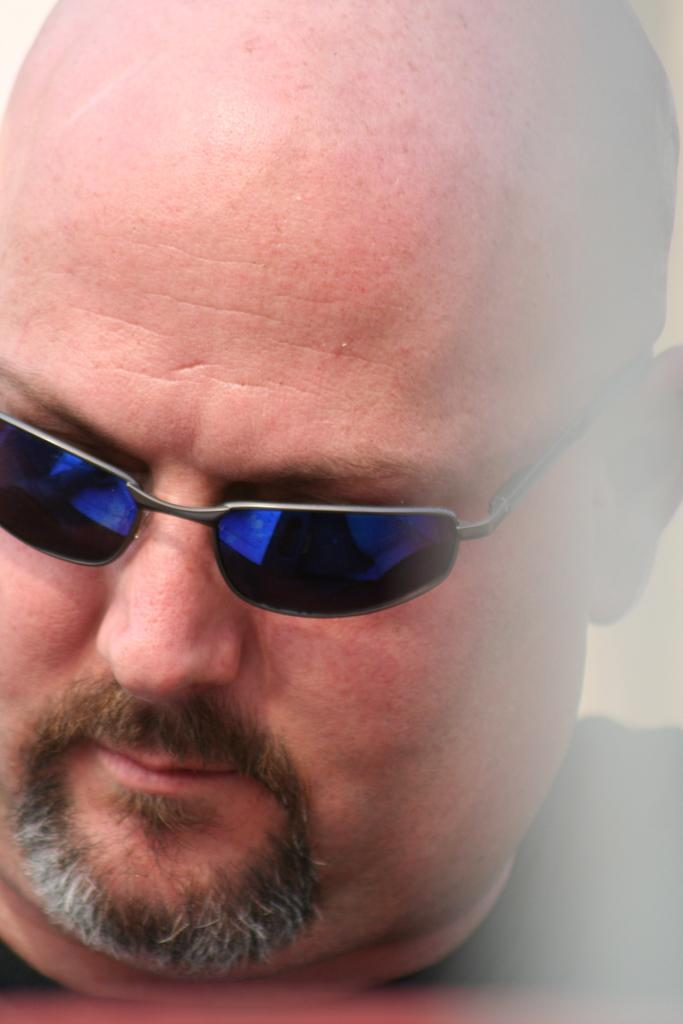What is the main subject of the image? There is a person in the image. Can you describe the person's appearance? The person is wearing spectacles. What type of grass can be seen growing around the mice in the image? There are no mice or grass present in the image; it features a person wearing spectacles. 